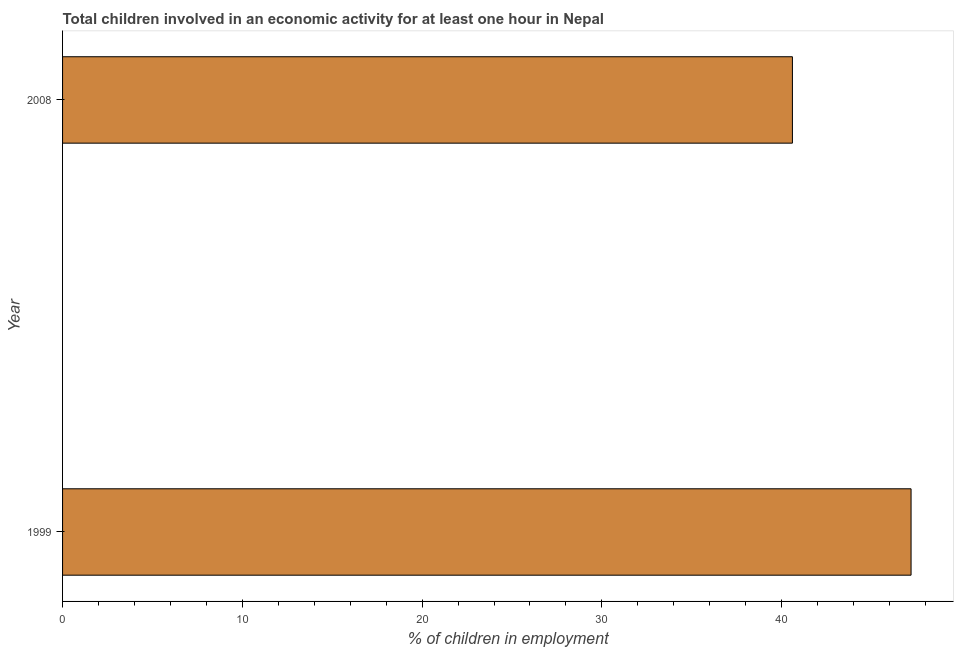Does the graph contain grids?
Provide a short and direct response. No. What is the title of the graph?
Ensure brevity in your answer.  Total children involved in an economic activity for at least one hour in Nepal. What is the label or title of the X-axis?
Your answer should be very brief. % of children in employment. What is the label or title of the Y-axis?
Give a very brief answer. Year. What is the percentage of children in employment in 2008?
Provide a succinct answer. 40.6. Across all years, what is the maximum percentage of children in employment?
Offer a very short reply. 47.2. Across all years, what is the minimum percentage of children in employment?
Offer a very short reply. 40.6. In which year was the percentage of children in employment maximum?
Your response must be concise. 1999. What is the sum of the percentage of children in employment?
Provide a succinct answer. 87.8. What is the average percentage of children in employment per year?
Provide a succinct answer. 43.9. What is the median percentage of children in employment?
Keep it short and to the point. 43.9. In how many years, is the percentage of children in employment greater than 40 %?
Ensure brevity in your answer.  2. Do a majority of the years between 1999 and 2008 (inclusive) have percentage of children in employment greater than 34 %?
Your response must be concise. Yes. What is the ratio of the percentage of children in employment in 1999 to that in 2008?
Ensure brevity in your answer.  1.16. In how many years, is the percentage of children in employment greater than the average percentage of children in employment taken over all years?
Your answer should be compact. 1. How many bars are there?
Ensure brevity in your answer.  2. Are all the bars in the graph horizontal?
Give a very brief answer. Yes. How many years are there in the graph?
Your response must be concise. 2. Are the values on the major ticks of X-axis written in scientific E-notation?
Make the answer very short. No. What is the % of children in employment of 1999?
Provide a short and direct response. 47.2. What is the % of children in employment in 2008?
Make the answer very short. 40.6. What is the difference between the % of children in employment in 1999 and 2008?
Make the answer very short. 6.6. What is the ratio of the % of children in employment in 1999 to that in 2008?
Provide a succinct answer. 1.16. 